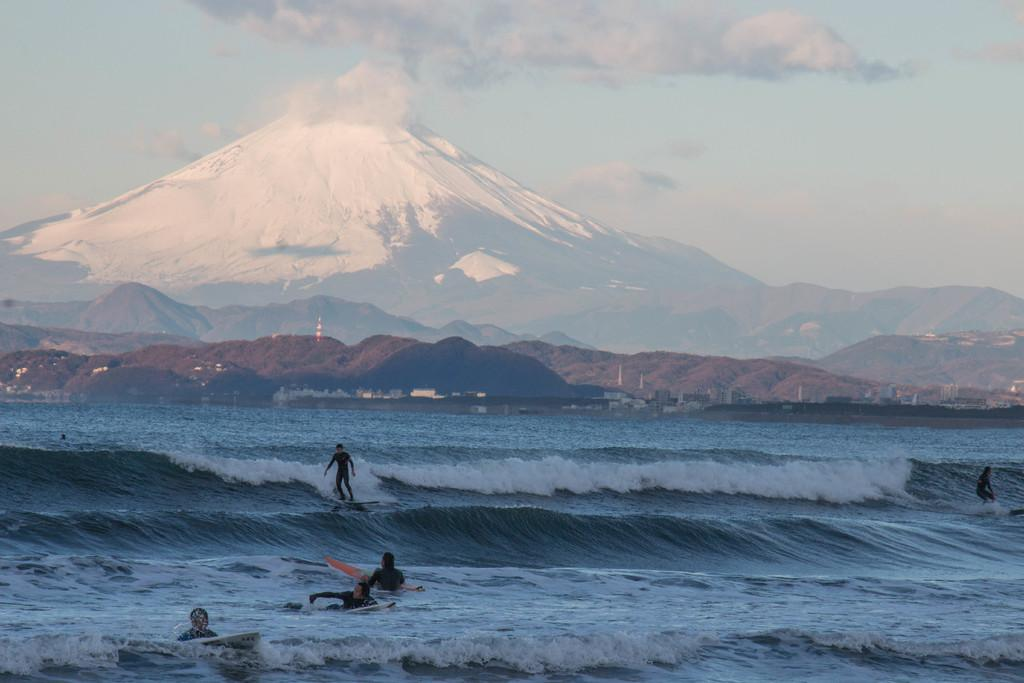What are the persons in the image doing? The persons in the image are surfing on waves. What can be seen in the background of the image? There are mountains and a cloudy sky in the background of the image. How many oranges are being used by the surfers in the image? There are no oranges present in the image; the persons are surfing on waves. Can you tell me how many kittens are playing on the channel in the image? There are no kittens or channels present in the image. 